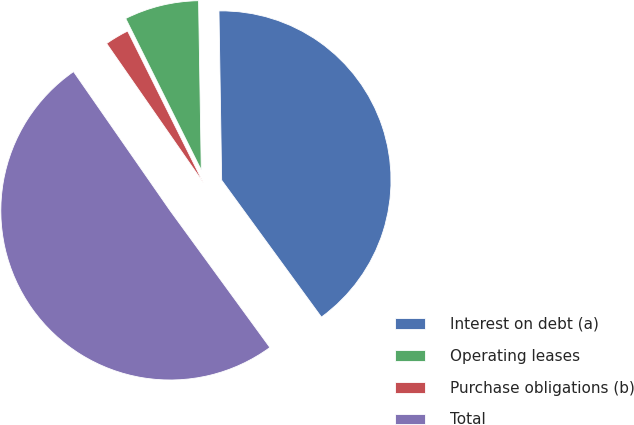Convert chart to OTSL. <chart><loc_0><loc_0><loc_500><loc_500><pie_chart><fcel>Interest on debt (a)<fcel>Operating leases<fcel>Purchase obligations (b)<fcel>Total<nl><fcel>40.23%<fcel>7.11%<fcel>2.3%<fcel>50.36%<nl></chart> 